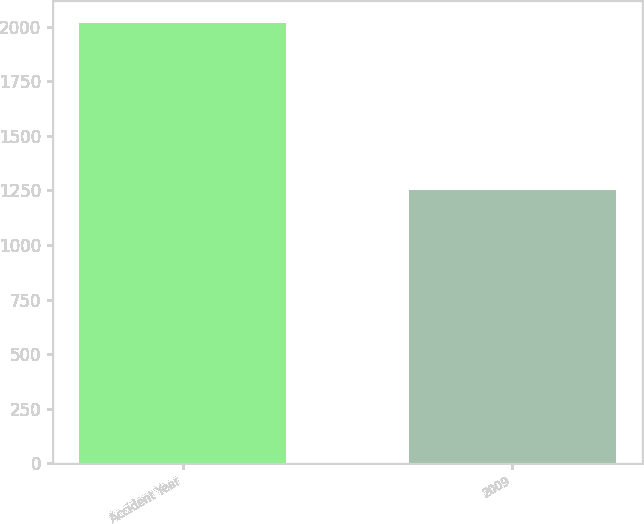Convert chart. <chart><loc_0><loc_0><loc_500><loc_500><bar_chart><fcel>Accident Year<fcel>2009<nl><fcel>2016<fcel>1250<nl></chart> 